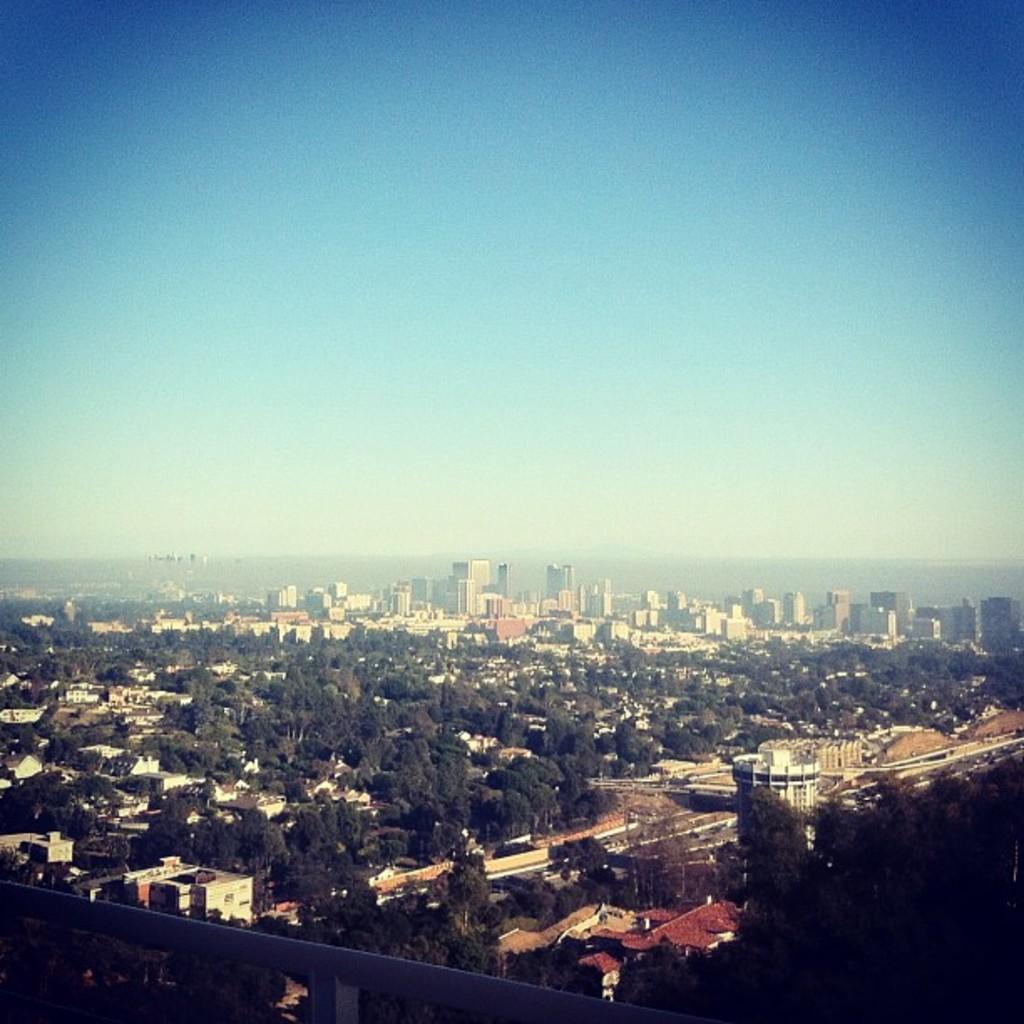Could you give a brief overview of what you see in this image? This is an outside view. At the bottom, I can see many trees and buildings. At the top of the image I can see the sky. 